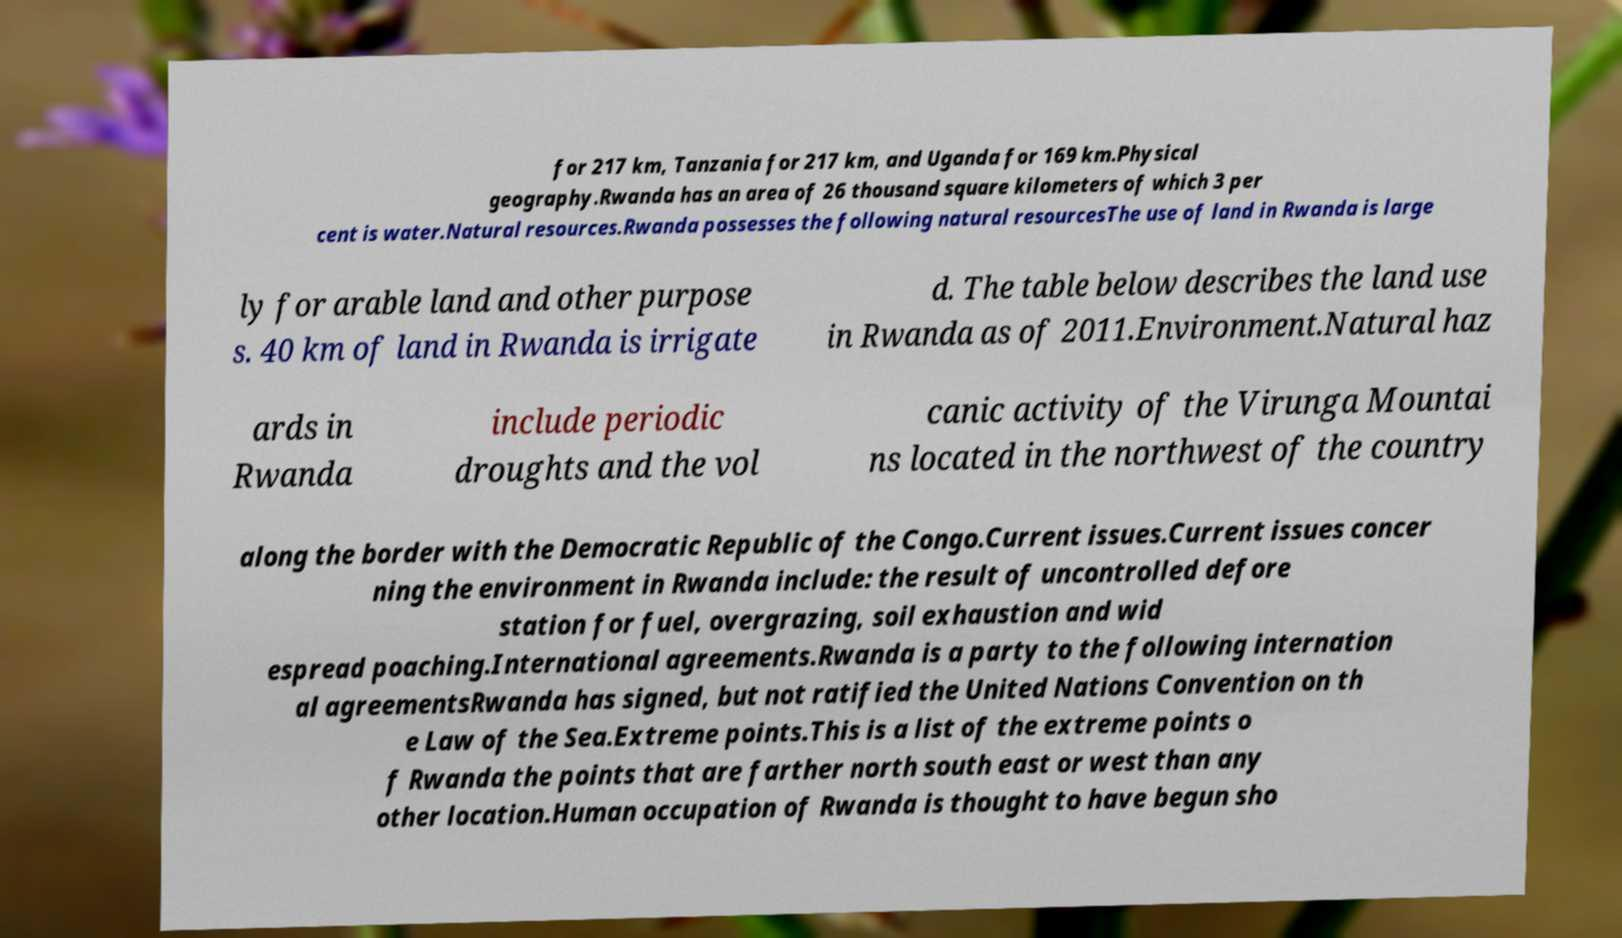Can you accurately transcribe the text from the provided image for me? for 217 km, Tanzania for 217 km, and Uganda for 169 km.Physical geography.Rwanda has an area of 26 thousand square kilometers of which 3 per cent is water.Natural resources.Rwanda possesses the following natural resourcesThe use of land in Rwanda is large ly for arable land and other purpose s. 40 km of land in Rwanda is irrigate d. The table below describes the land use in Rwanda as of 2011.Environment.Natural haz ards in Rwanda include periodic droughts and the vol canic activity of the Virunga Mountai ns located in the northwest of the country along the border with the Democratic Republic of the Congo.Current issues.Current issues concer ning the environment in Rwanda include: the result of uncontrolled defore station for fuel, overgrazing, soil exhaustion and wid espread poaching.International agreements.Rwanda is a party to the following internation al agreementsRwanda has signed, but not ratified the United Nations Convention on th e Law of the Sea.Extreme points.This is a list of the extreme points o f Rwanda the points that are farther north south east or west than any other location.Human occupation of Rwanda is thought to have begun sho 